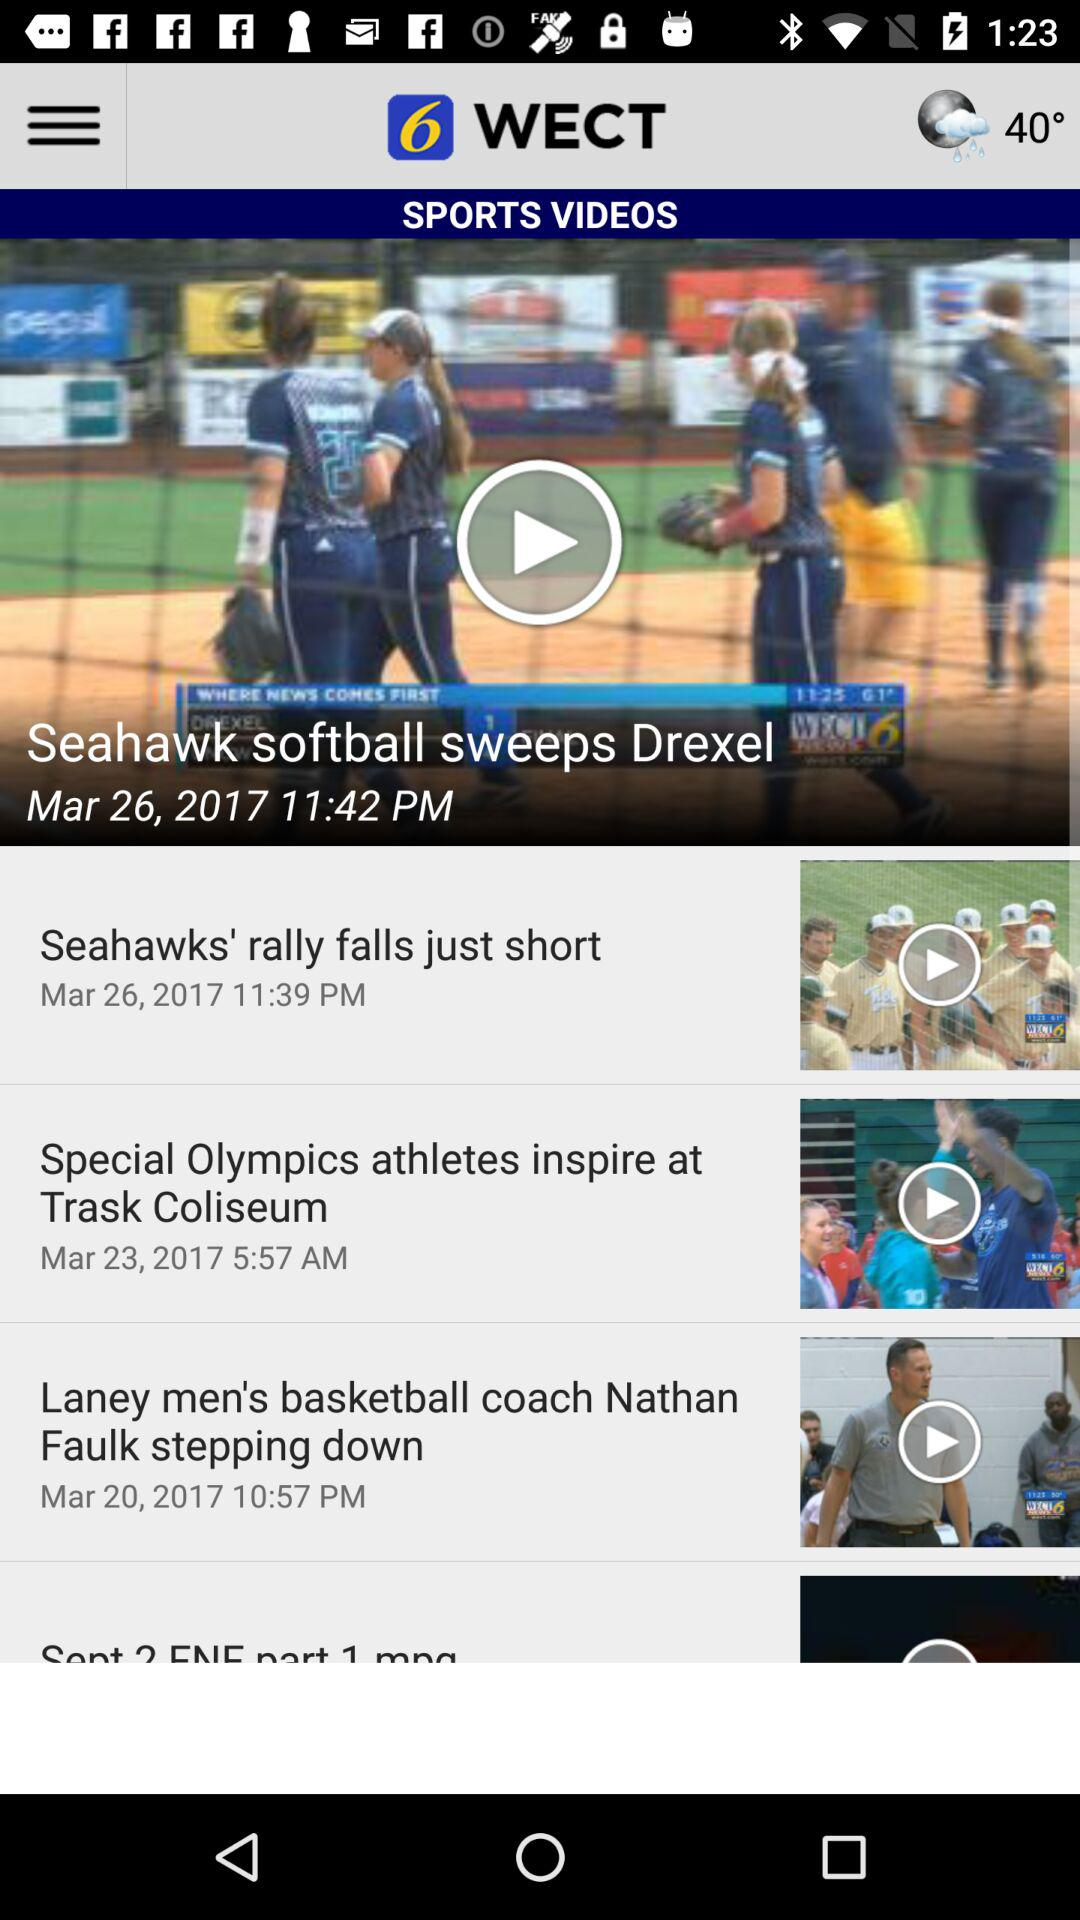At what time was "Seahawk softball sweeps Drexel" news uploaded? The news "Seahawk softball sweeps Drexel" was uploaded at 11:42 p.m. 